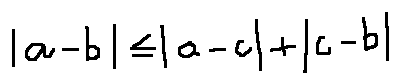Convert formula to latex. <formula><loc_0><loc_0><loc_500><loc_500>| a - b | \leq | a - c | + | c - b |</formula> 